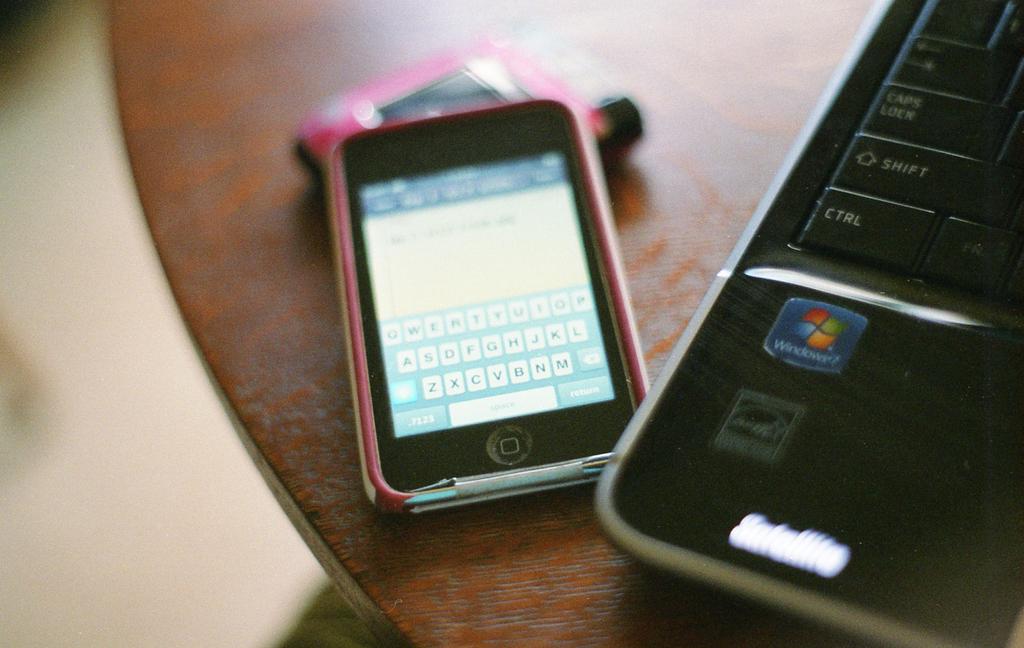What type of phone is that?
Your answer should be compact. Unanswerable. What does the blue label on the right phone say?
Offer a terse response. Windows. 